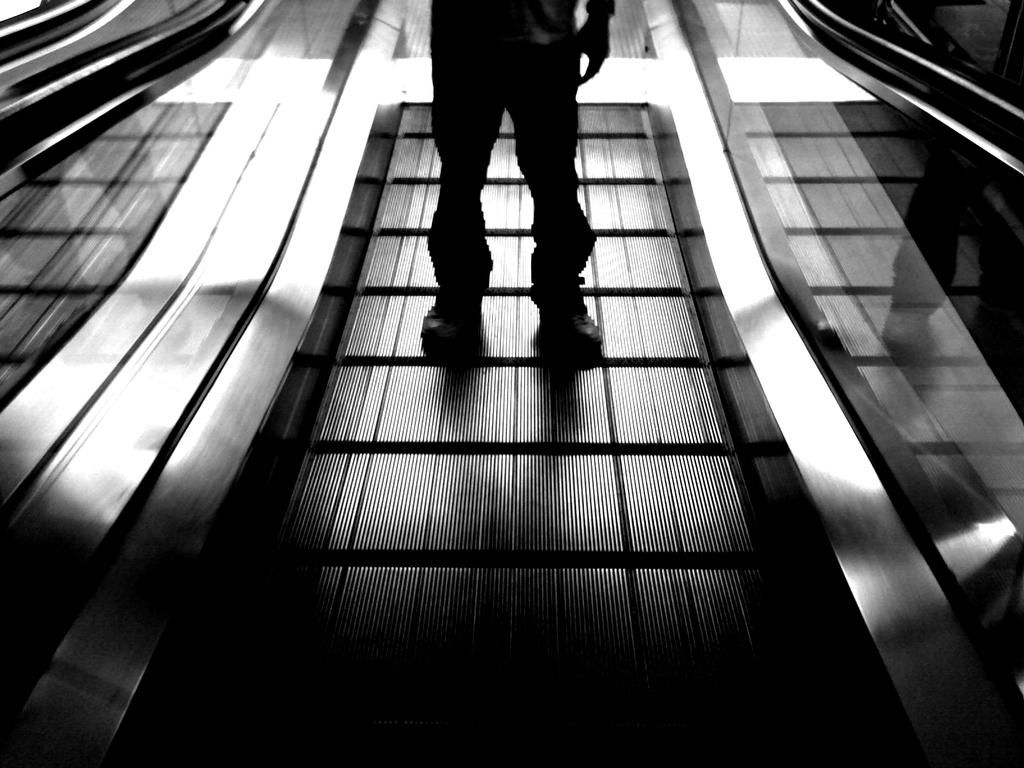What is the color scheme of the image? The image is black and white. What is the person in the image doing? The person is standing on an escalator. What type of eyewear is the person wearing? The person is wearing transparent glasses on the left and right side. What type of pen is the person holding in the image? There is no pen visible in the image; the person is wearing transparent glasses on the left and right side. Can you describe the person's smile in the image? The image is black and white, and there is no indication of the person's facial expression, including a smile. 